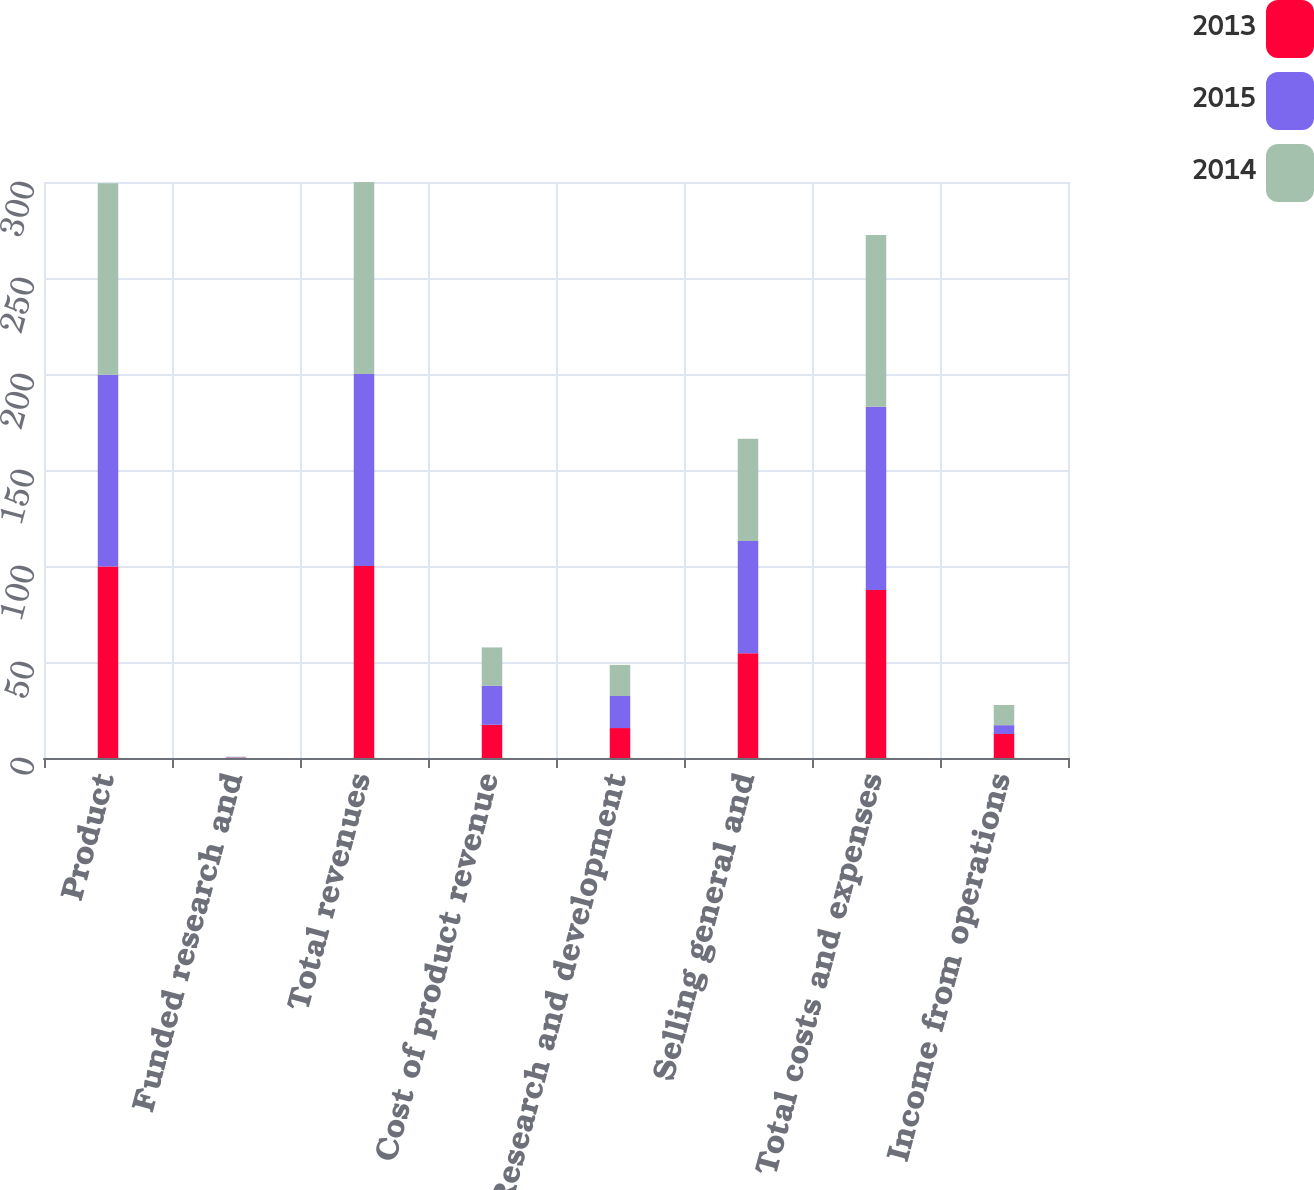Convert chart. <chart><loc_0><loc_0><loc_500><loc_500><stacked_bar_chart><ecel><fcel>Product<fcel>Funded research and<fcel>Total revenues<fcel>Cost of product revenue<fcel>Research and development<fcel>Selling general and<fcel>Total costs and expenses<fcel>Income from operations<nl><fcel>2013<fcel>99.8<fcel>0.2<fcel>100<fcel>17.3<fcel>15.6<fcel>54.6<fcel>87.5<fcel>12.5<nl><fcel>2015<fcel>99.8<fcel>0.2<fcel>100<fcel>20.3<fcel>16.7<fcel>58.4<fcel>95.4<fcel>4.6<nl><fcel>2014<fcel>99.7<fcel>0.3<fcel>100<fcel>20<fcel>16.2<fcel>53.3<fcel>89.5<fcel>10.5<nl></chart> 